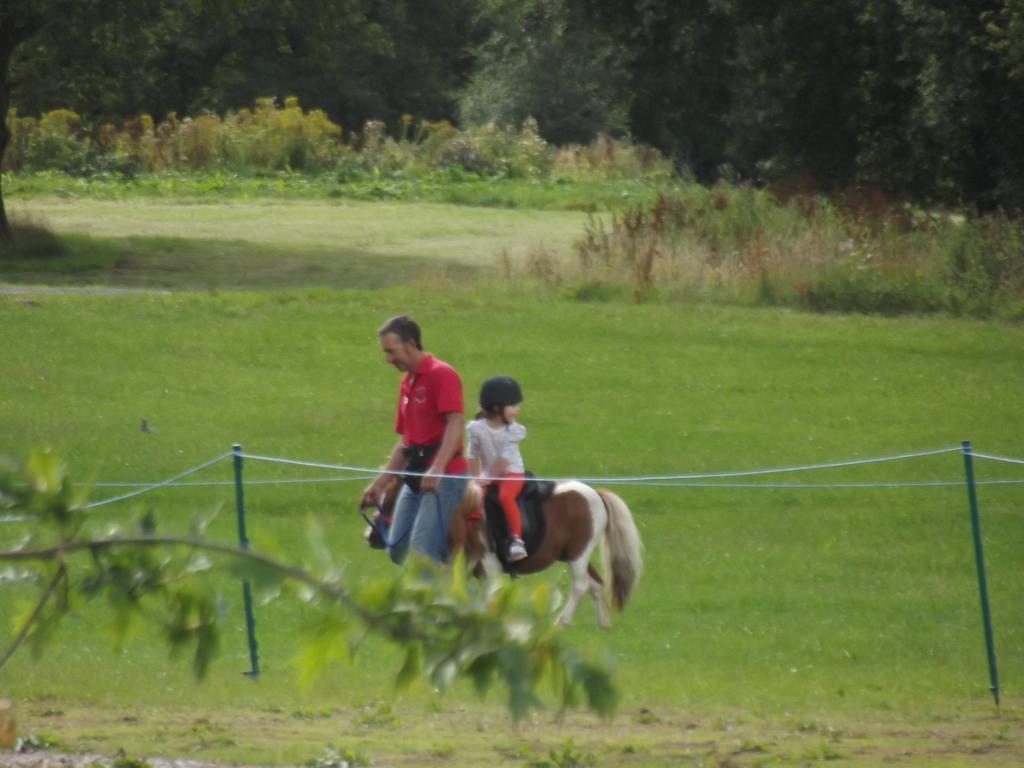Could you give a brief overview of what you see in this image? In the image there is a man walking on the grassland, behind him there is a girl sitting on a horse. 